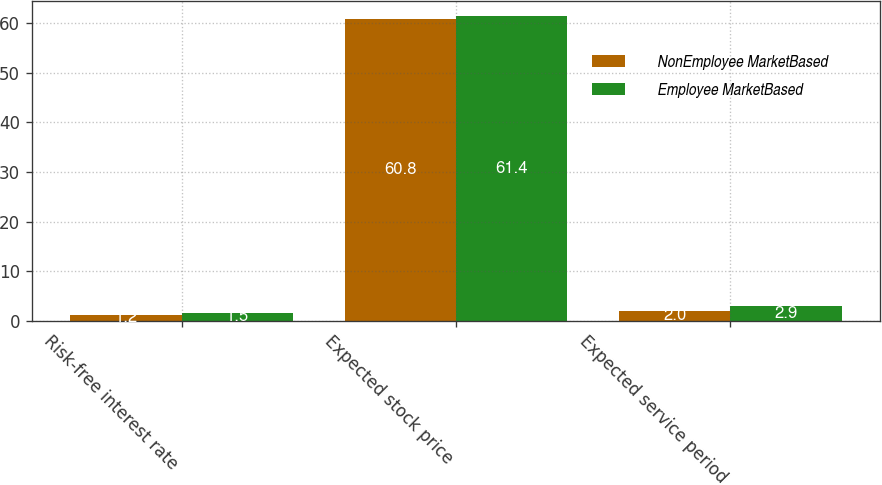<chart> <loc_0><loc_0><loc_500><loc_500><stacked_bar_chart><ecel><fcel>Risk-free interest rate<fcel>Expected stock price<fcel>Expected service period<nl><fcel>NonEmployee MarketBased<fcel>1.2<fcel>60.8<fcel>2<nl><fcel>Employee MarketBased<fcel>1.5<fcel>61.4<fcel>2.9<nl></chart> 